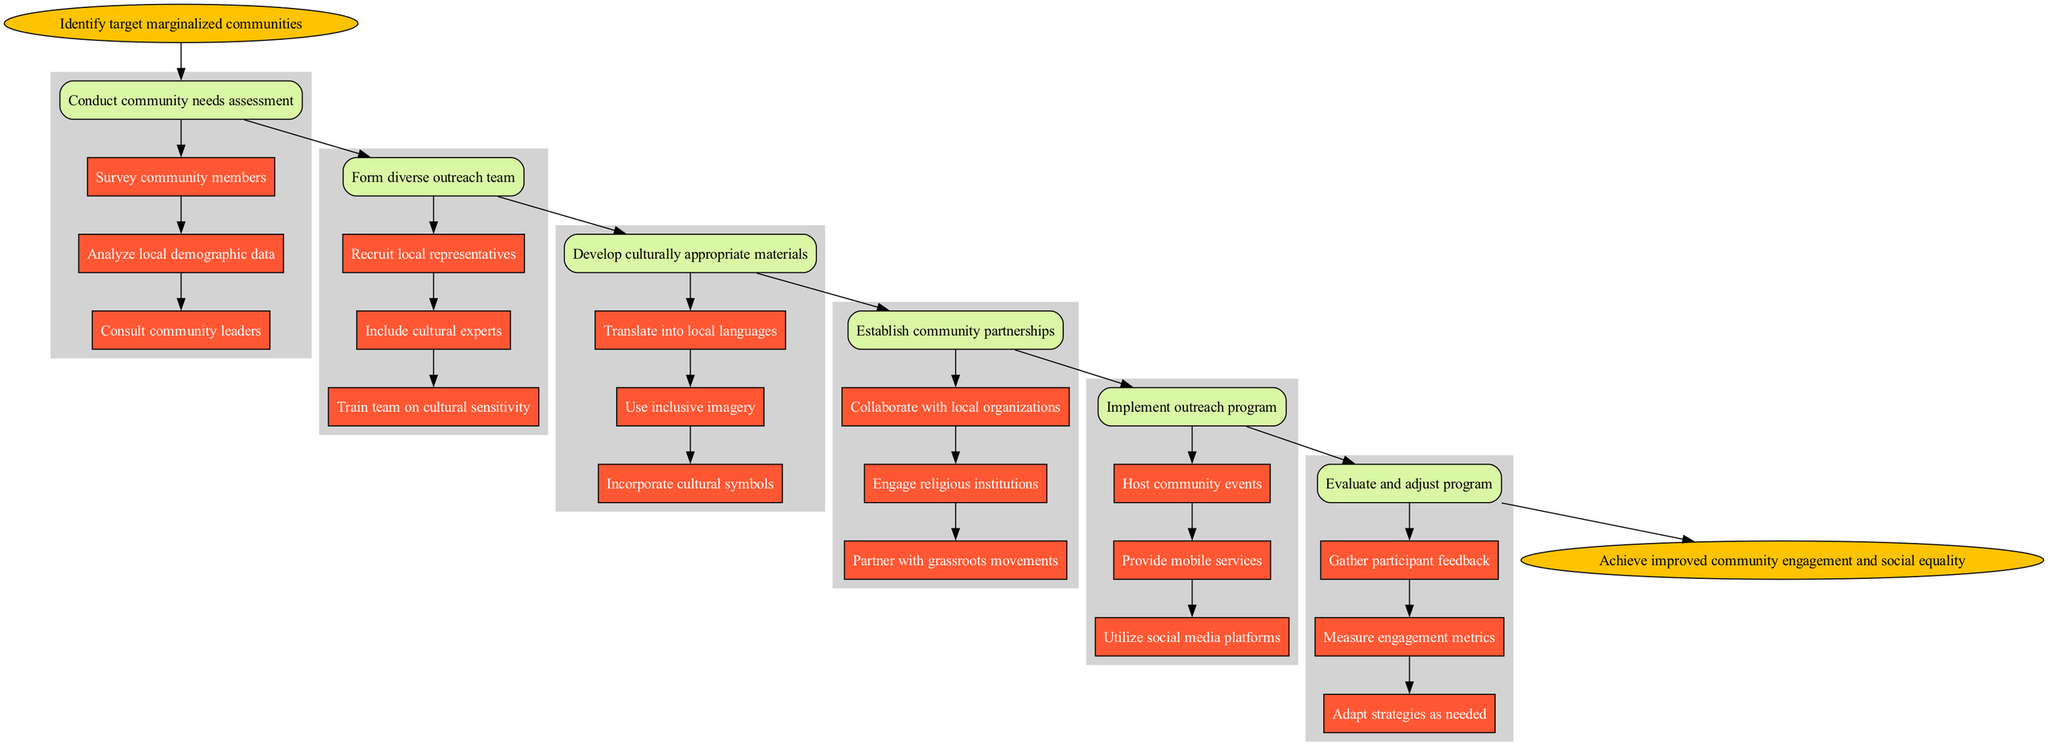What is the first step in the outreach program? The diagram starts with "Identify target marginalized communities," which is the initial step in the process.
Answer: Identify target marginalized communities How many steps are included in the outreach program? There are a total of six main steps in the diagram, from identifying the target communities to evaluating and adjusting the program.
Answer: 6 What are the substeps of the "Form diverse outreach team"? The substeps for this main step include: "Recruit local representatives," "Include cultural experts," and "Train team on cultural sensitivity." These are the detailed actions needed for this step.
Answer: Recruit local representatives, Include cultural experts, Train team on cultural sensitivity Which step directly follows the "Establish community partnerships"? The step that follows "Establish community partnerships" is "Implement outreach program." This indicates the logical sequence of actions after forming partnerships.
Answer: Implement outreach program How many substeps are there under "Evaluate and adjust program"? Under the step "Evaluate and adjust program," there are three substeps: "Gather participant feedback," "Measure engagement metrics," and "Adapt strategies as needed." This gives us a total of three detailed actions for evaluation.
Answer: 3 What color is used for the start and end nodes in the diagram? Both the start and end nodes are colored in a shade of yellow (fillcolor #FFC300), indicating the beginning and conclusion of the outreach process respectively.
Answer: Yellow What is the final goal of the outreach program? The ultimate aim of the outreach program is to "Achieve improved community engagement and social equality," which summarizes the desired outcome of the entire process.
Answer: Achieve improved community engagement and social equality Which two steps are connected by the edge labeled with "Collaborate with local organizations"? The edge labeled "Collaborate with local organizations" connects the "Establish community partnerships" step to the substep of the same name. This indicates a direct relationship between partnership formation and collaboration with local groups.
Answer: Establish community partnerships and Collaborate with local organizations What is the significance of including cultural experts in the outreach team? Including cultural experts is significant because it ensures the outreach program is informed by individuals who possess cultural knowledge crucial for addressing the needs of the marginalized communities being targeted.
Answer: Cultural sensitivity and effectiveness 